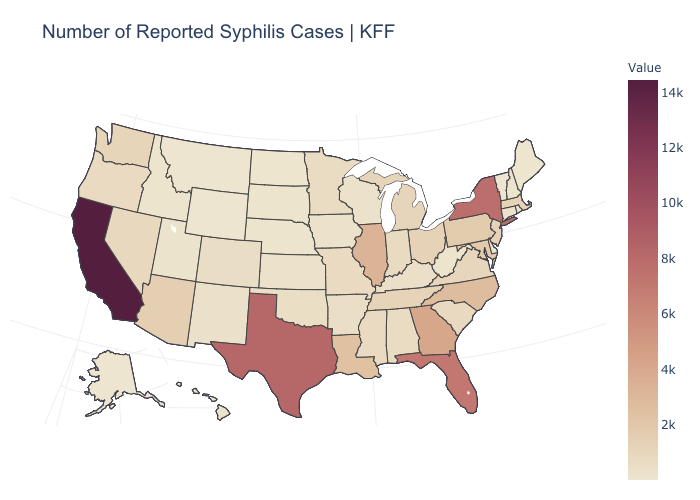Which states have the highest value in the USA?
Answer briefly. California. Which states have the lowest value in the USA?
Give a very brief answer. Wyoming. Which states hav the highest value in the South?
Answer briefly. Texas. Among the states that border New York , which have the highest value?
Short answer required. Pennsylvania. Is the legend a continuous bar?
Answer briefly. Yes. Among the states that border South Dakota , which have the highest value?
Short answer required. Minnesota. 